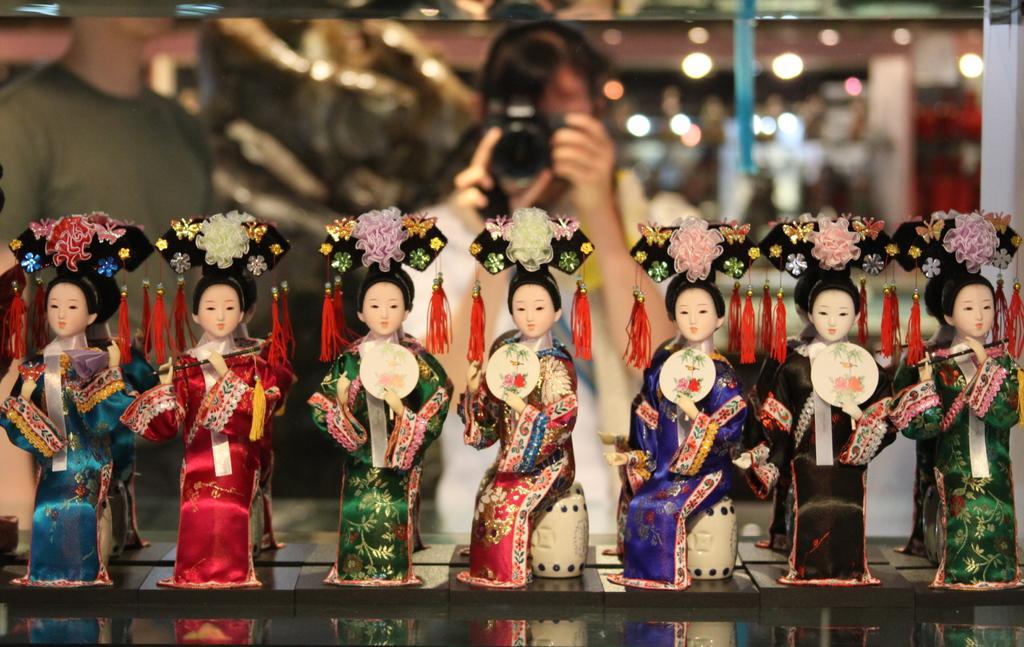How would you summarize this image in a sentence or two? This image is taken indoors. At the bottom of the image there is a table with a few beautiful dolls on it. In the background a woman is standing and clicking a picture with a camera. On the left side of the image there is a man. 